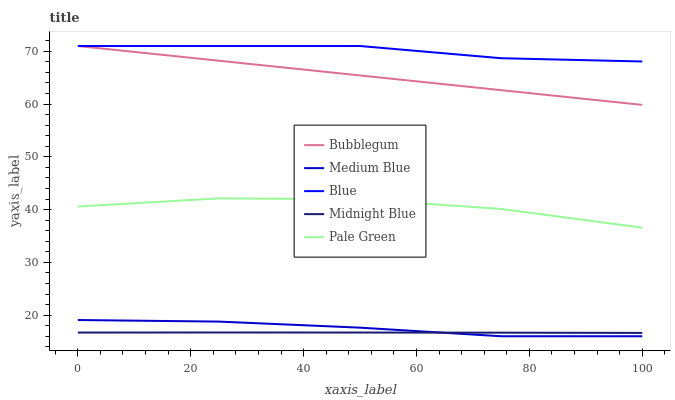Does Pale Green have the minimum area under the curve?
Answer yes or no. No. Does Pale Green have the maximum area under the curve?
Answer yes or no. No. Is Medium Blue the smoothest?
Answer yes or no. No. Is Medium Blue the roughest?
Answer yes or no. No. Does Pale Green have the lowest value?
Answer yes or no. No. Does Pale Green have the highest value?
Answer yes or no. No. Is Pale Green less than Blue?
Answer yes or no. Yes. Is Blue greater than Medium Blue?
Answer yes or no. Yes. Does Pale Green intersect Blue?
Answer yes or no. No. 